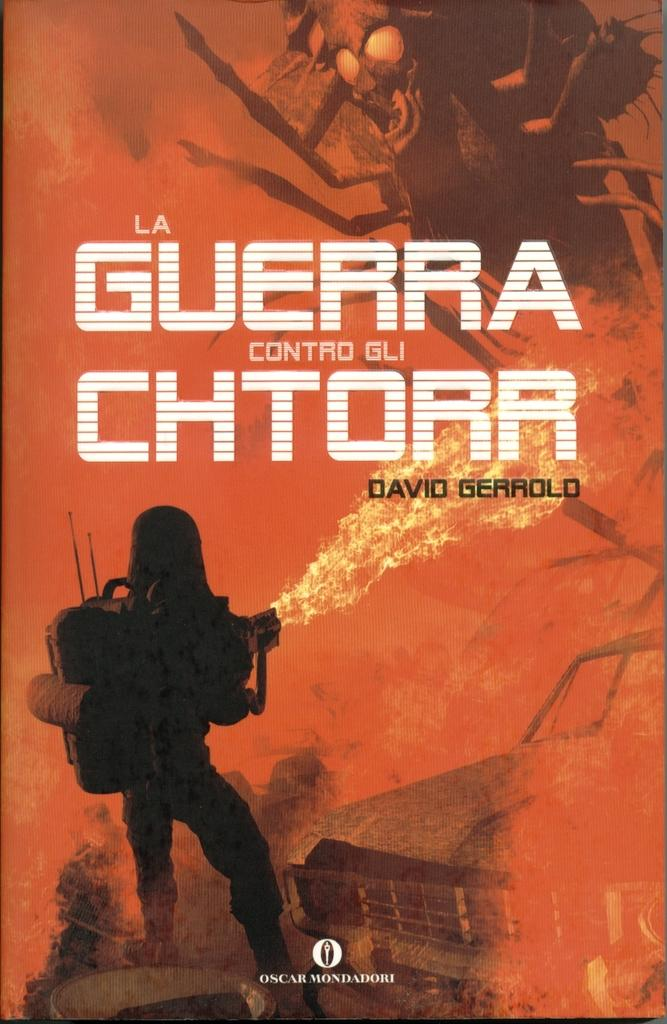Provide a one-sentence caption for the provided image. A man shoots a flamethrower in a burnt out hellscape on the cover of a David Gerrold book. 